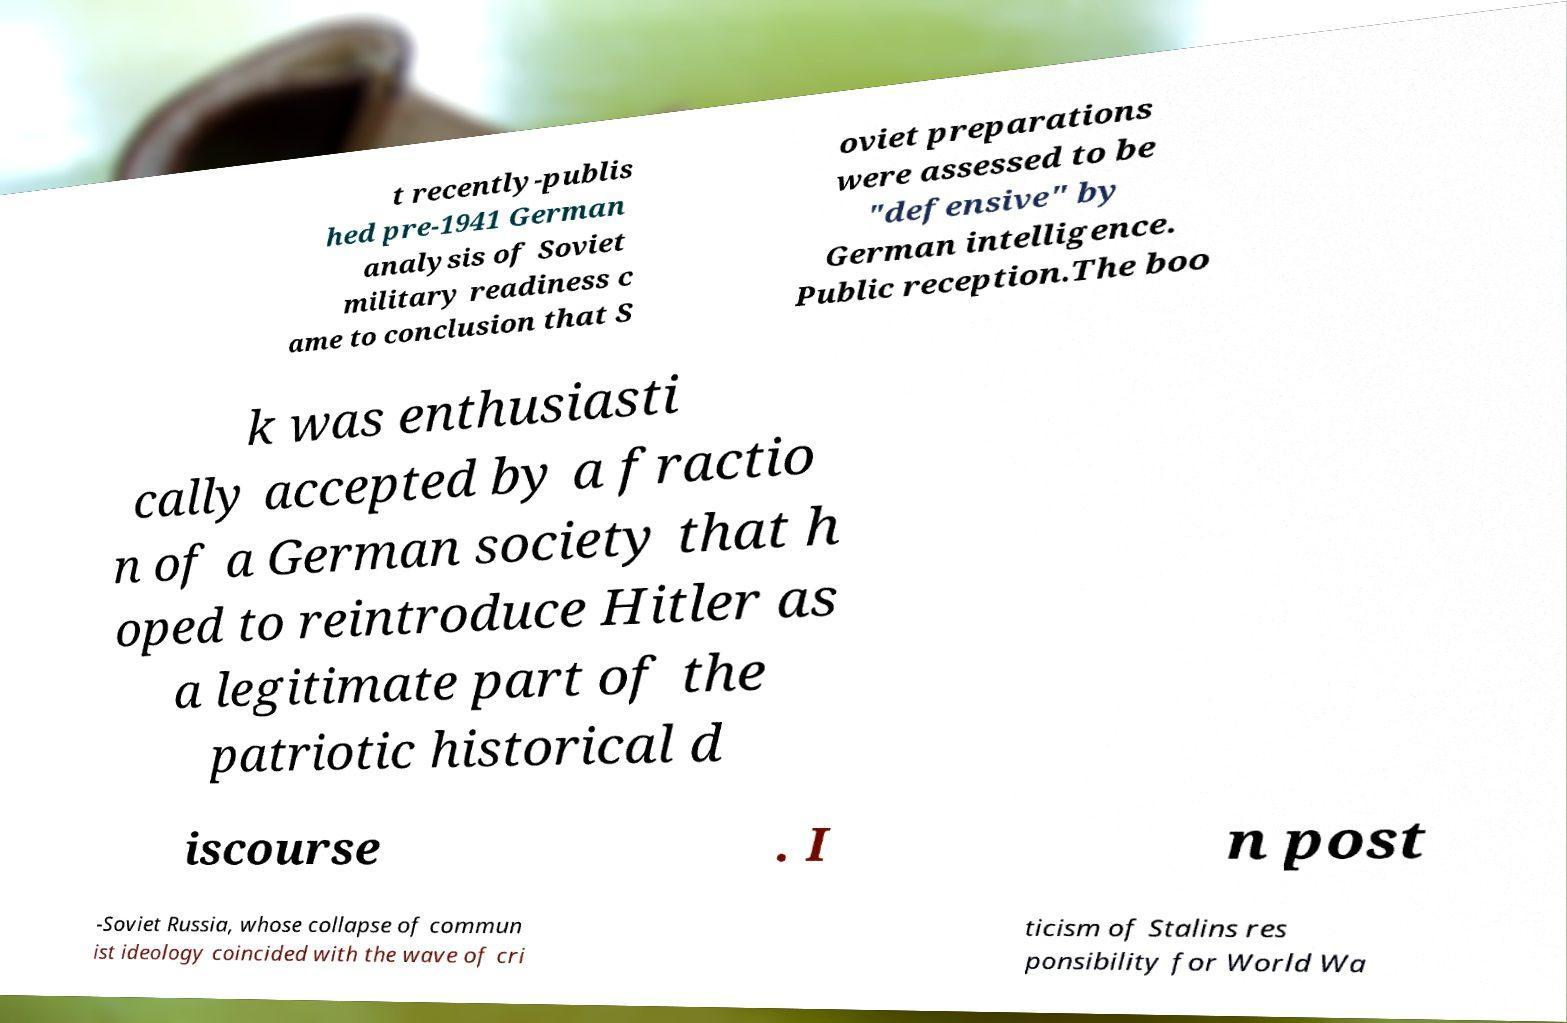There's text embedded in this image that I need extracted. Can you transcribe it verbatim? t recently-publis hed pre-1941 German analysis of Soviet military readiness c ame to conclusion that S oviet preparations were assessed to be "defensive" by German intelligence. Public reception.The boo k was enthusiasti cally accepted by a fractio n of a German society that h oped to reintroduce Hitler as a legitimate part of the patriotic historical d iscourse . I n post -Soviet Russia, whose collapse of commun ist ideology coincided with the wave of cri ticism of Stalins res ponsibility for World Wa 